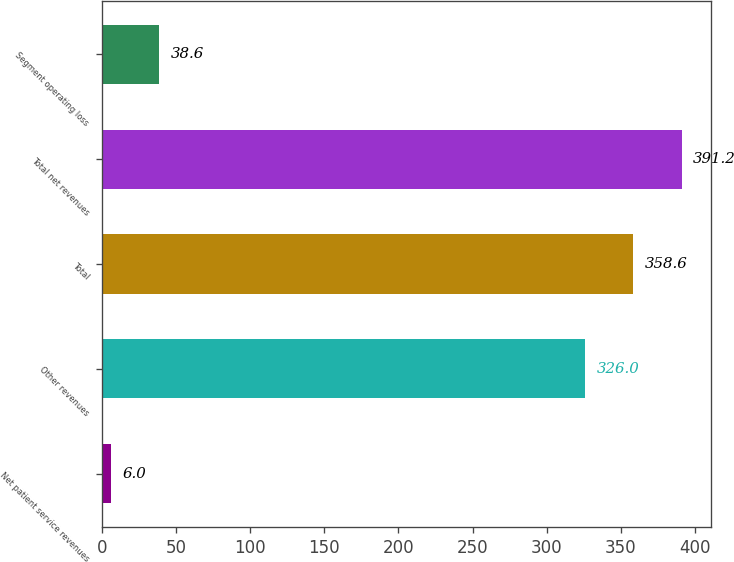Convert chart to OTSL. <chart><loc_0><loc_0><loc_500><loc_500><bar_chart><fcel>Net patient service revenues<fcel>Other revenues<fcel>Total<fcel>Total net revenues<fcel>Segment operating loss<nl><fcel>6<fcel>326<fcel>358.6<fcel>391.2<fcel>38.6<nl></chart> 